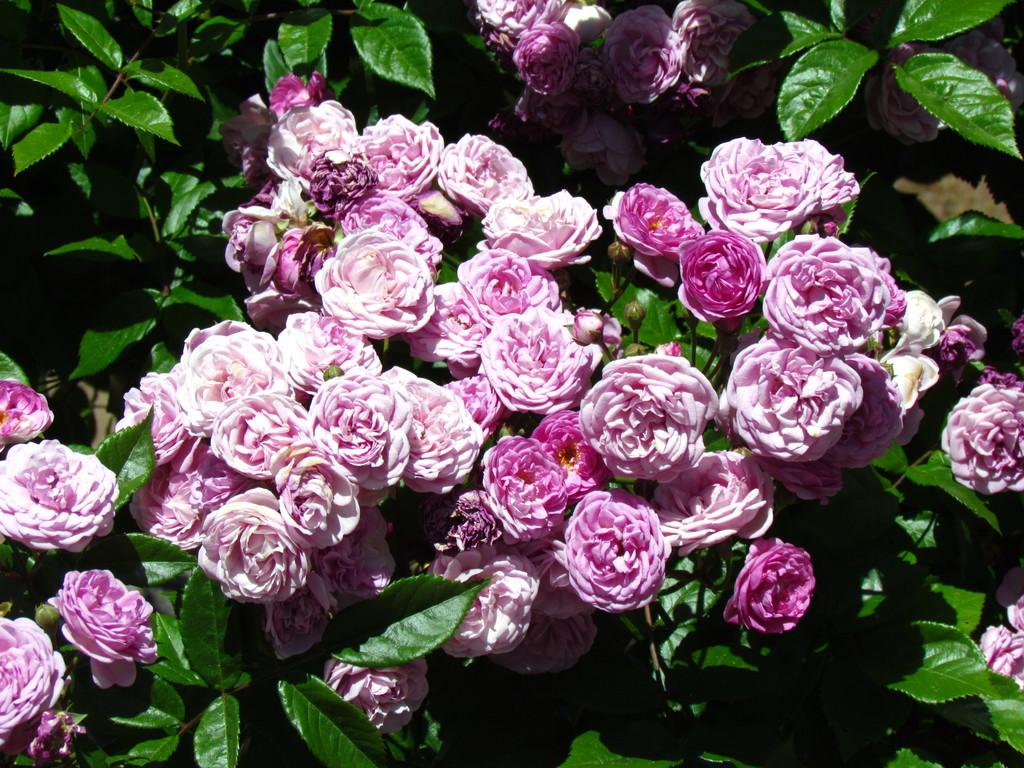What type of vegetation can be seen in the image? There are leaves in the image. What color are the flowers in the image? There are pink color flowers in the image. What type of event is taking place in the image? There is no event present in the image; it only features leaves and flowers. What type of collar can be seen on the flowers in the image? There are no collars present in the image; it only features leaves and flowers. 